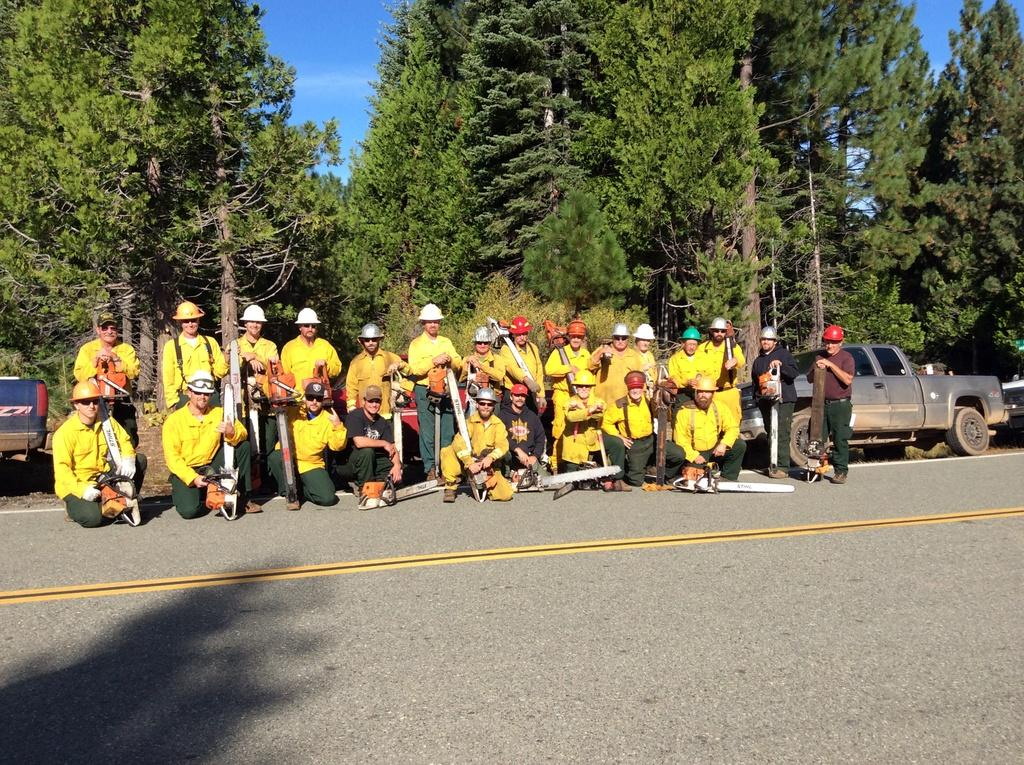What is happening in the image involving a group of people? There is a group of people in the image, and they are holding something in their hands. What can be seen beside the road in the image? There are vehicles visible beside the road in the image. What is visible in the background of the image? There are trees visible in the background of the image. What type of door can be seen in the image? There is no door present in the image. Is there an argument happening between the people in the image? There is no indication of an argument in the image; the people are simply holding something in their hands. 